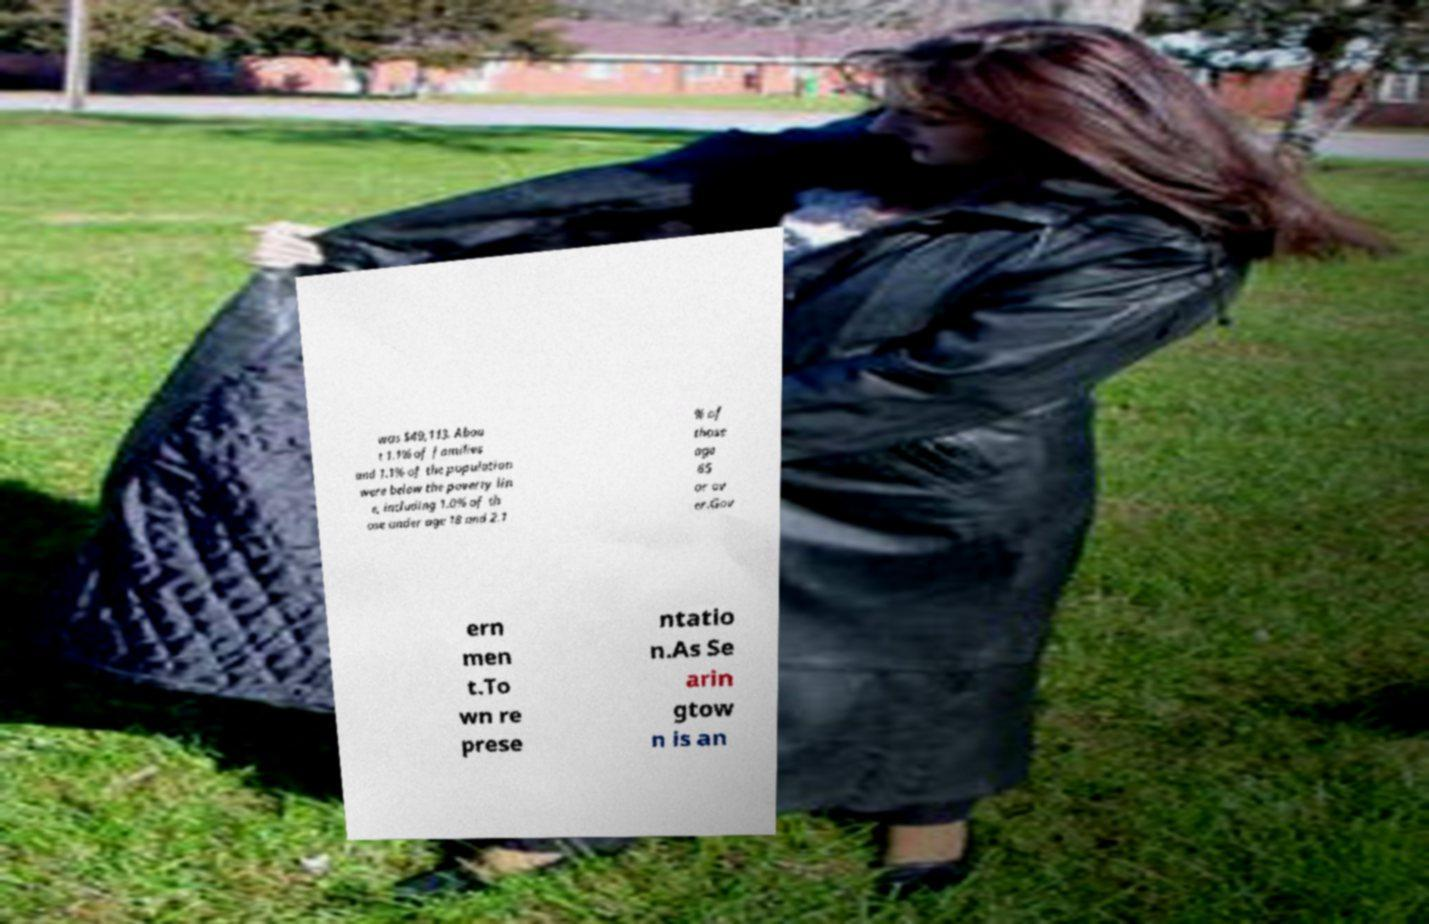Please identify and transcribe the text found in this image. was $49,113. Abou t 1.1% of families and 1.1% of the population were below the poverty lin e, including 1.0% of th ose under age 18 and 2.1 % of those age 65 or ov er.Gov ern men t.To wn re prese ntatio n.As Se arin gtow n is an 